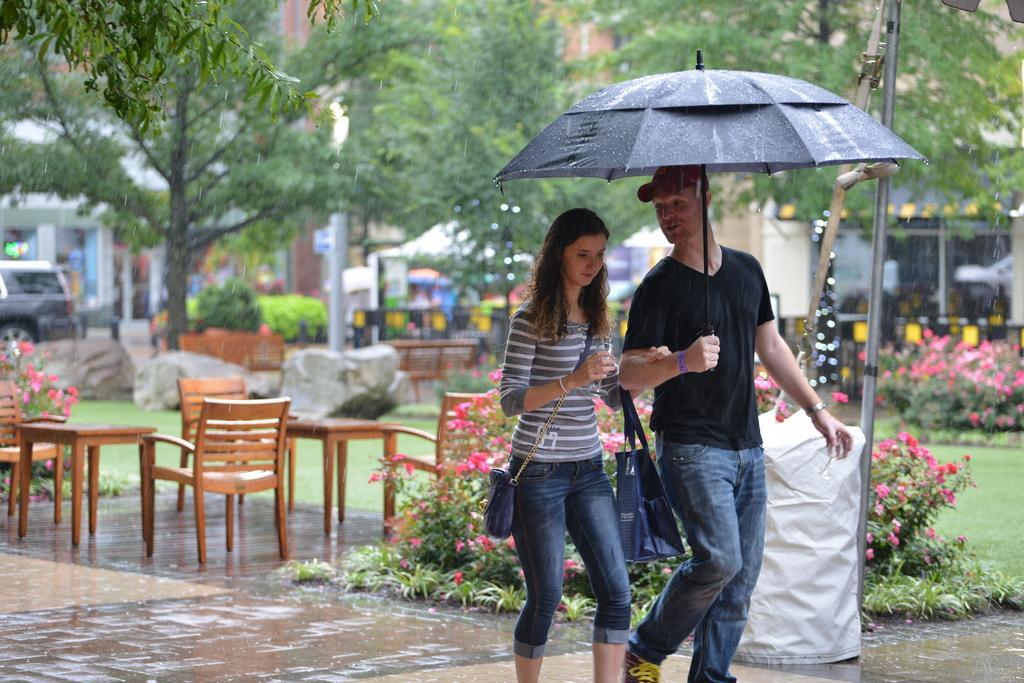Can you describe this image briefly? Here is the man and woman walking. They are holding umbrella and bags in their hands. These are the chairs and tables. I can see flower plants. This looks like a pole. At background I can see trees and buildings. here is the car parked. These are the rocks. This looks like a bench. 